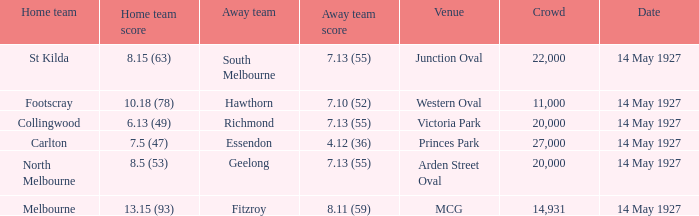Which place accommodated a home team with a score of 1 MCG. 